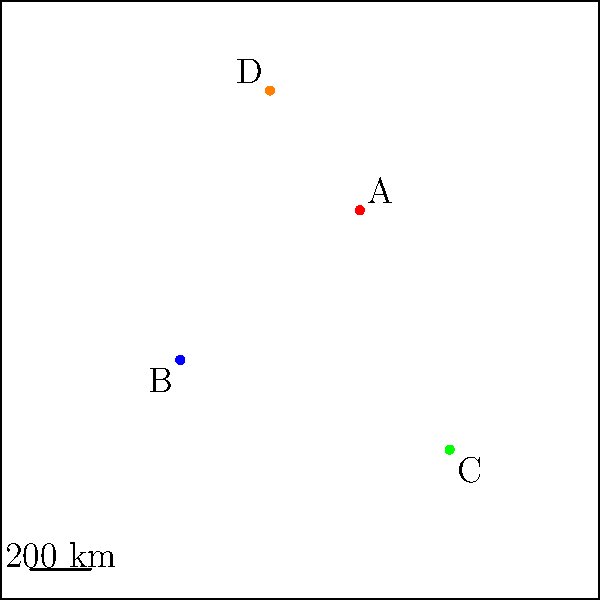As a music historian, you've discovered four rare audio files (A, B, C, and D) from different locations. Given that the scale on the map represents 200 km, what is the approximate total distance covered if you were to visit all four locations in the order A-B-C-D, starting and ending at point A? To solve this problem, we need to follow these steps:

1. Calculate the distances between consecutive points:
   a) A to B: Using the distance formula, $\sqrt{(x_2-x_1)^2 + (y_2-y_1)^2}$
      $\sqrt{(-4-2)^2 + (-2-3)^2} = \sqrt{36 + 25} = \sqrt{61} \approx 7.81$ units
   
   b) B to C: $\sqrt{(5-(-4))^2 + (-5-(-2))^2} = \sqrt{81 + 9} = \sqrt{90} \approx 9.49$ units
   
   c) C to D: $\sqrt{(-1-5)^2 + (7-(-5))^2} = \sqrt{36 + 144} = \sqrt{180} \approx 13.42$ units
   
   d) D to A (to complete the circuit): $\sqrt{(2-(-1))^2 + (3-7)^2} = \sqrt{9 + 16} = \sqrt{25} = 5$ units

2. Sum up all the distances:
   Total distance in units = 7.81 + 9.49 + 13.42 + 5 ≈ 35.72 units

3. Convert units to kilometers using the scale:
   2 units = 200 km
   1 unit = 100 km
   35.72 units * 100 km/unit = 3572 km

Therefore, the approximate total distance covered is 3572 km.
Answer: 3572 km 